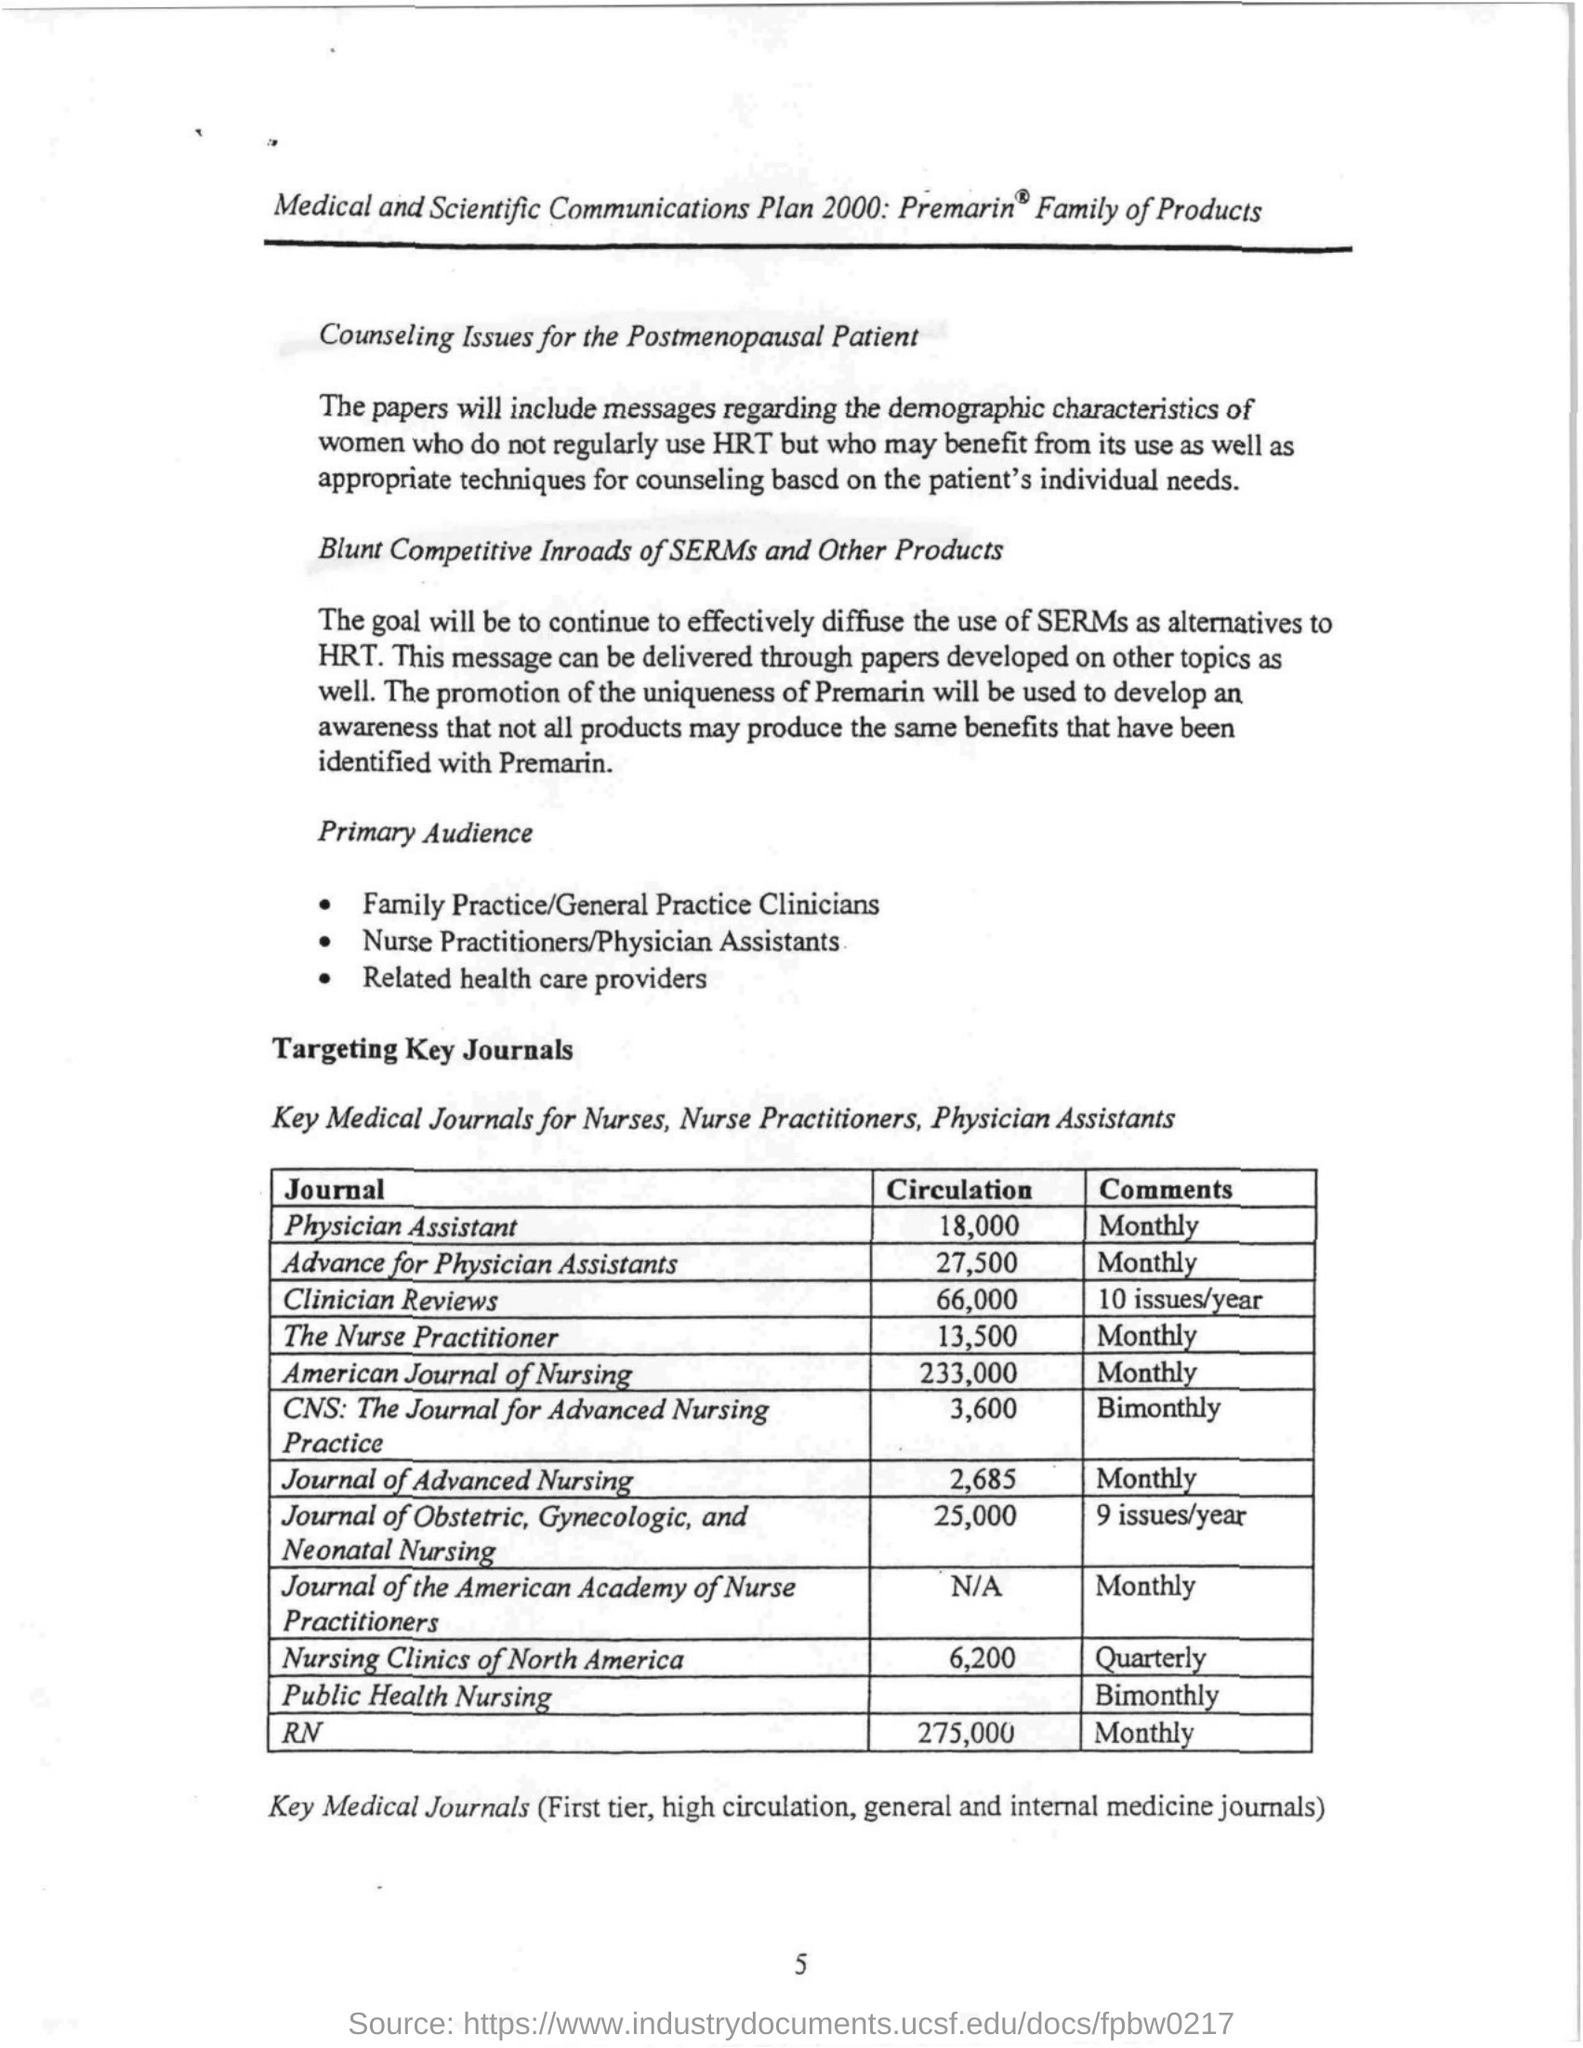How many circulations are there for american journal of nursing monthly?
Provide a short and direct response. 233,000. What is the circulation of journal of the american academy of nurse practitioner?
Your response must be concise. N/A. What is the name of the journal with 10 issues/year?
Your answer should be compact. Clinician Reviews. What is the name of the journal with quaterly in comments ?
Your response must be concise. Nursing Clinics of North America. 